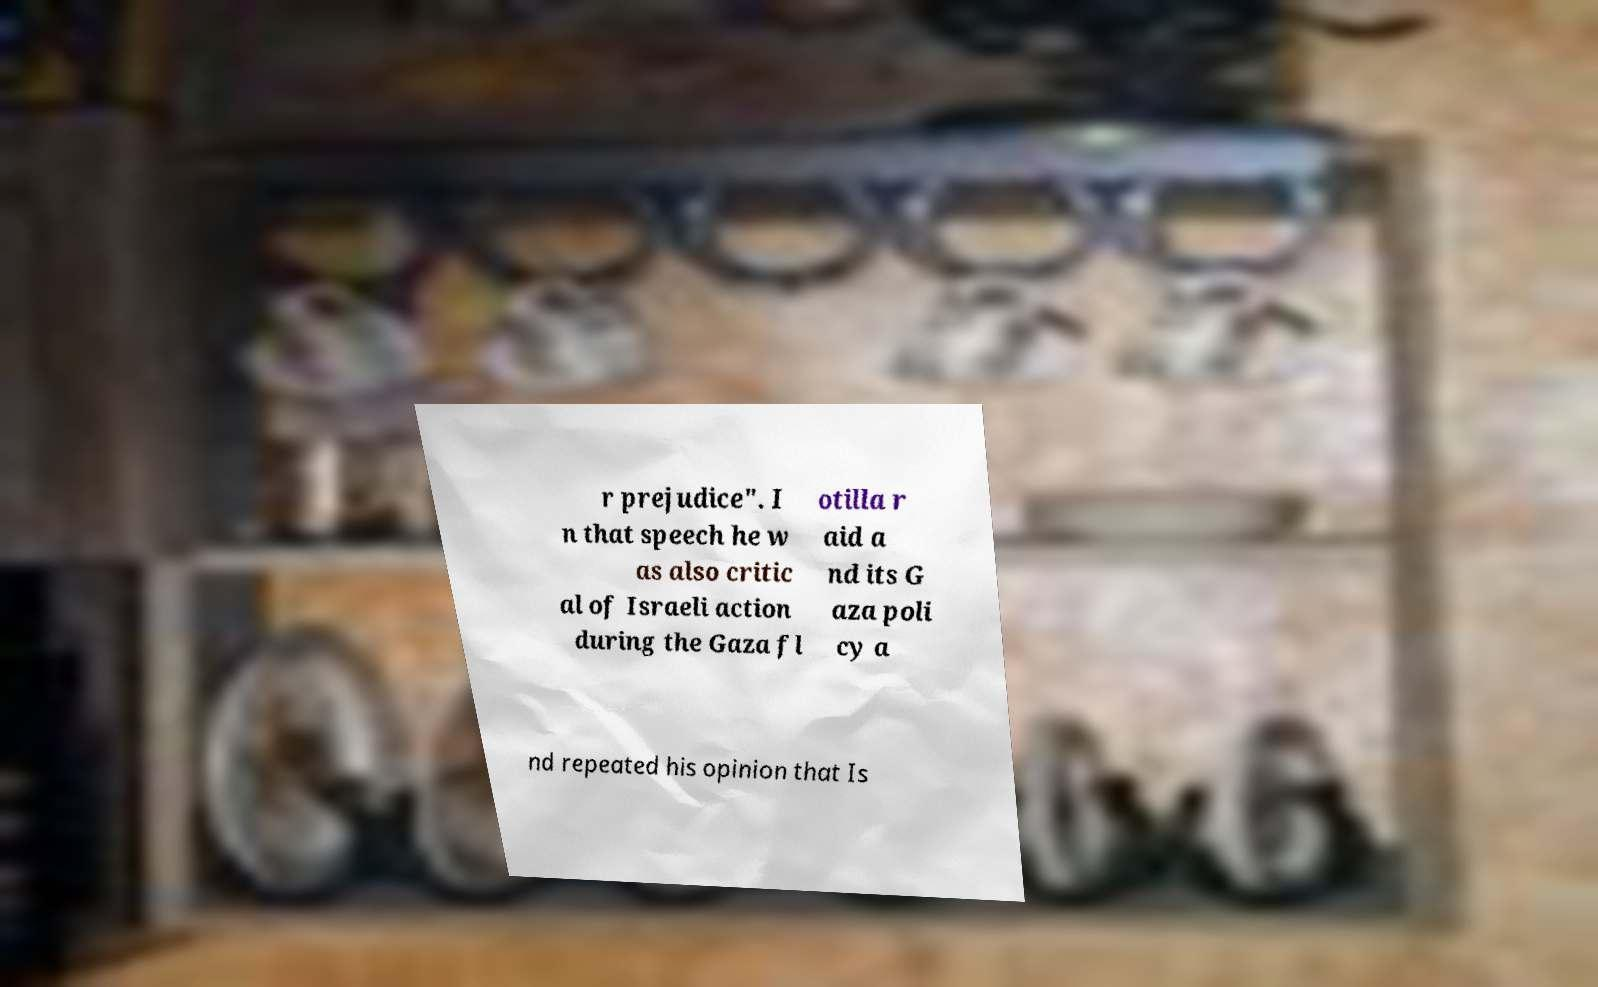Could you extract and type out the text from this image? r prejudice". I n that speech he w as also critic al of Israeli action during the Gaza fl otilla r aid a nd its G aza poli cy a nd repeated his opinion that Is 